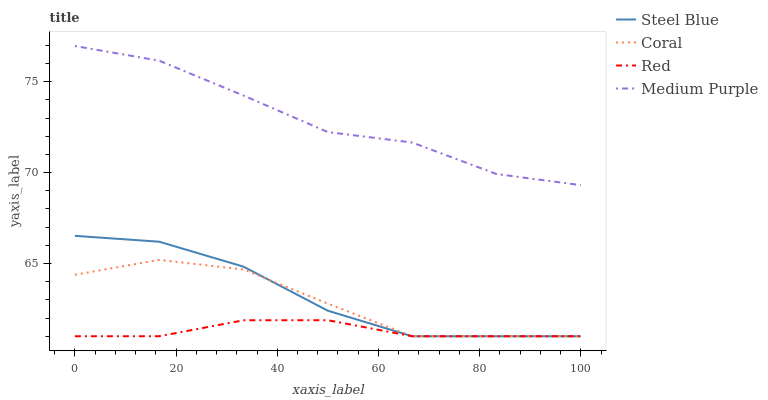Does Red have the minimum area under the curve?
Answer yes or no. Yes. Does Medium Purple have the maximum area under the curve?
Answer yes or no. Yes. Does Coral have the minimum area under the curve?
Answer yes or no. No. Does Coral have the maximum area under the curve?
Answer yes or no. No. Is Red the smoothest?
Answer yes or no. Yes. Is Medium Purple the roughest?
Answer yes or no. Yes. Is Coral the smoothest?
Answer yes or no. No. Is Coral the roughest?
Answer yes or no. No. Does Coral have the lowest value?
Answer yes or no. Yes. Does Medium Purple have the highest value?
Answer yes or no. Yes. Does Coral have the highest value?
Answer yes or no. No. Is Steel Blue less than Medium Purple?
Answer yes or no. Yes. Is Medium Purple greater than Coral?
Answer yes or no. Yes. Does Steel Blue intersect Red?
Answer yes or no. Yes. Is Steel Blue less than Red?
Answer yes or no. No. Is Steel Blue greater than Red?
Answer yes or no. No. Does Steel Blue intersect Medium Purple?
Answer yes or no. No. 